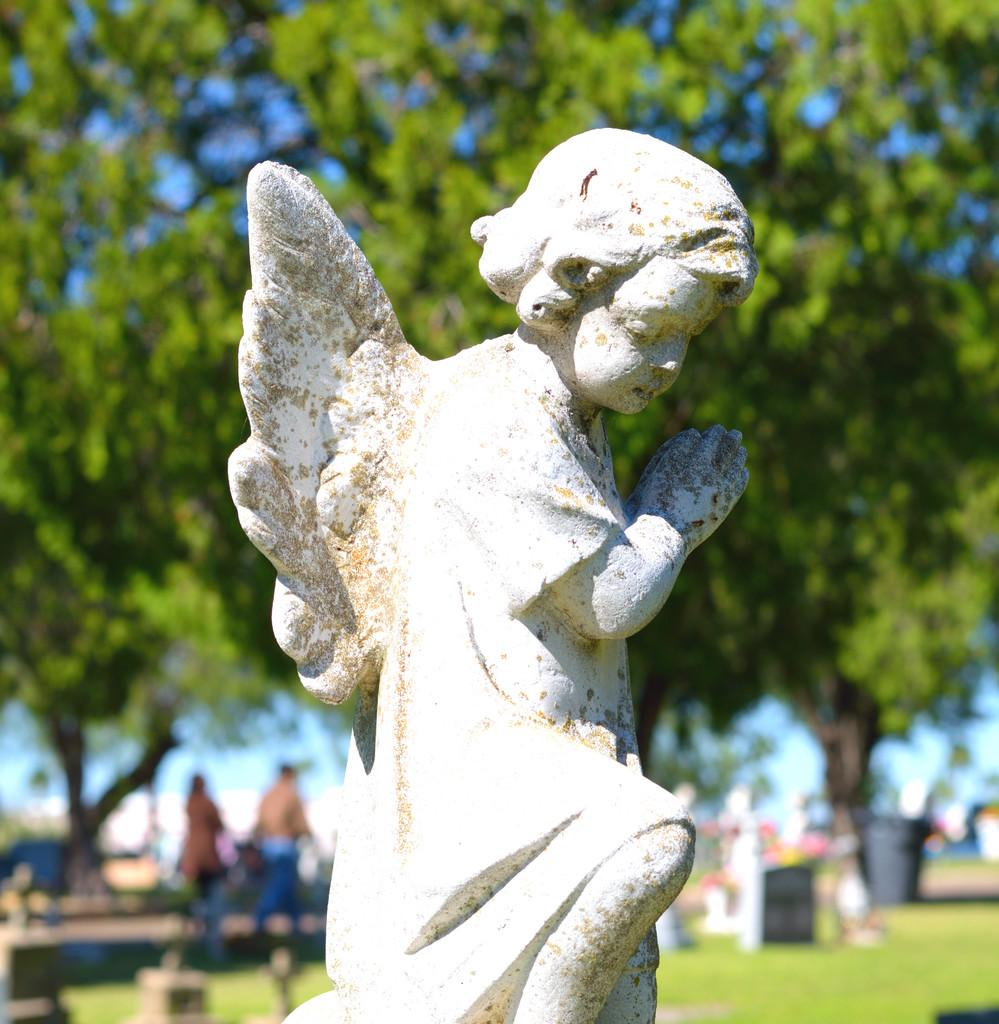What is the main subject in the middle of the image? There is a statue in the middle of the image. What can be seen in the background of the image? There are trees, grass, and a group of people in the background of the image. What type of dinner is being served to the women in the image? There are no women or dinner present in the image; it features a statue and a background with trees, grass, and a group of people. 